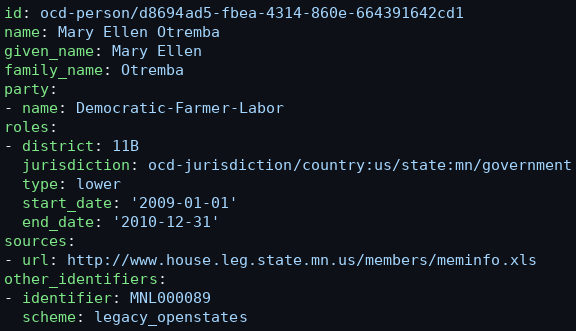<code> <loc_0><loc_0><loc_500><loc_500><_YAML_>id: ocd-person/d8694ad5-fbea-4314-860e-664391642cd1
name: Mary Ellen Otremba
given_name: Mary Ellen
family_name: Otremba
party:
- name: Democratic-Farmer-Labor
roles:
- district: 11B
  jurisdiction: ocd-jurisdiction/country:us/state:mn/government
  type: lower
  start_date: '2009-01-01'
  end_date: '2010-12-31'
sources:
- url: http://www.house.leg.state.mn.us/members/meminfo.xls
other_identifiers:
- identifier: MNL000089
  scheme: legacy_openstates
</code> 